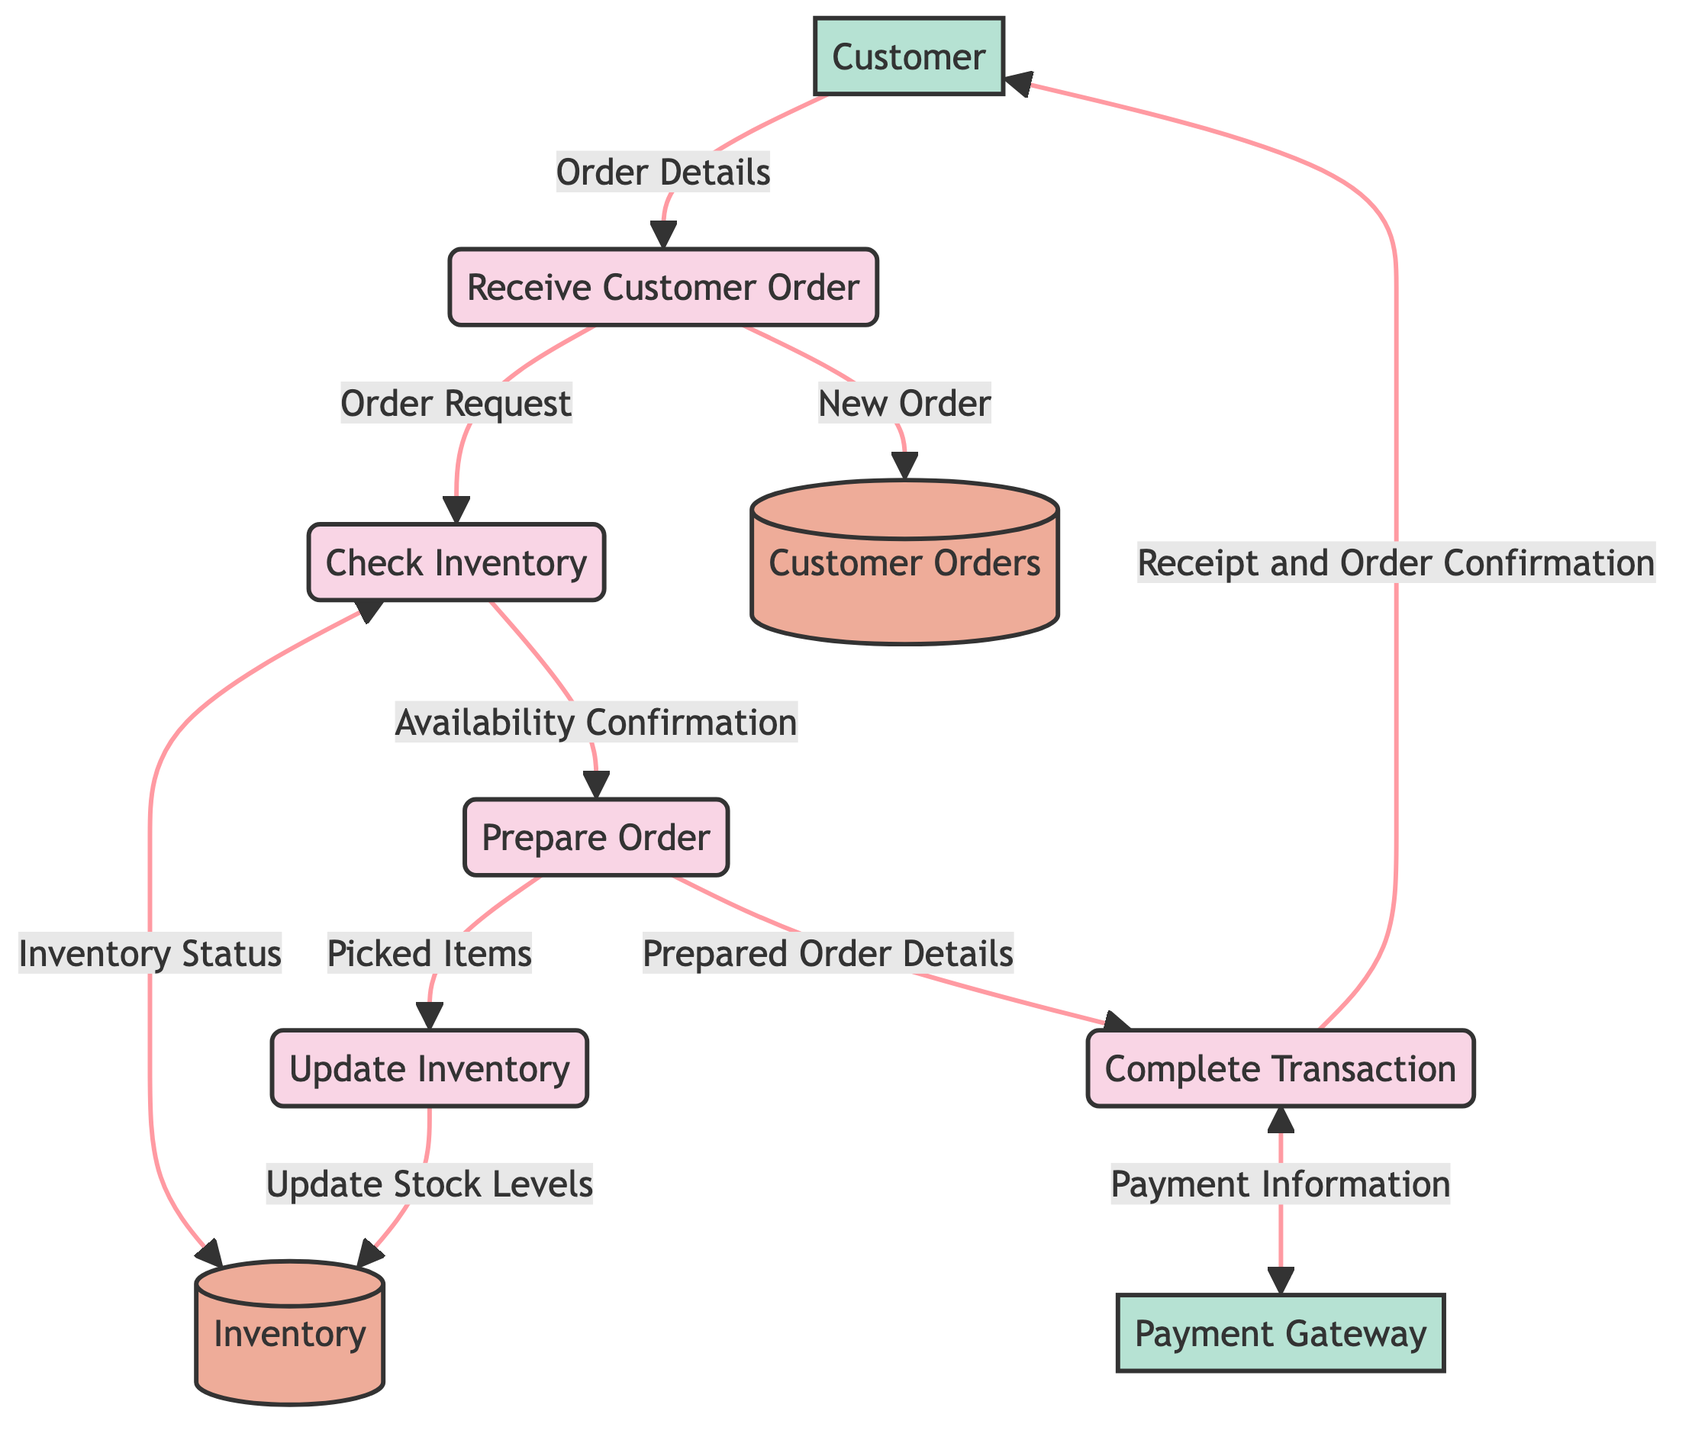What is the first process in the workflow? The diagram starts with the process "Receive Customer Order," indicating that this is the first step in the workflow.
Answer: Receive Customer Order How many data stores are present in the diagram? The diagram contains two data stores: "Customer Orders" and "Inventory." Therefore, the total count is two.
Answer: 2 Which external entity processes the payment? The external entity responsible for processing payments is labeled "Payment Gateway" in the diagram.
Answer: Payment Gateway What is the last step in the customer order fulfillment process? The diagram shows that the last process completed is "Complete Transaction," followed by providing a receipt to the customer.
Answer: Complete Transaction Which process is directly connected to "Check Inventory"? The "Check Inventory" process is directly connected to the "Receive Customer Order" process, as it receives the "Order Request" from it.
Answer: Receive Customer Order What data flow moves from "Prepare Order" to "Complete Transaction"? The data flow named "Prepared Order Details" moves from "Prepare Order" to "Complete Transaction." This indicates the details packaged for the transaction are sent.
Answer: Prepared Order Details Which node responds to the inventory status request? The "Inventory" datastore responds to the "Check Inventory" process by providing the "Inventory Status Response."
Answer: Inventory What is the relationship between "Update Inventory" and "Inventory"? The "Update Inventory" process sends the "Update Stock Levels" flow to the "Inventory" datastore, indicating that inventory levels are being adjusted based on processed orders.
Answer: Update Stock Levels How many total processes are in the diagram? The diagram includes five processes: "Receive Customer Order," "Check Inventory," "Prepare Order," "Update Inventory," and "Complete Transaction." Therefore, the count is five.
Answer: 5 